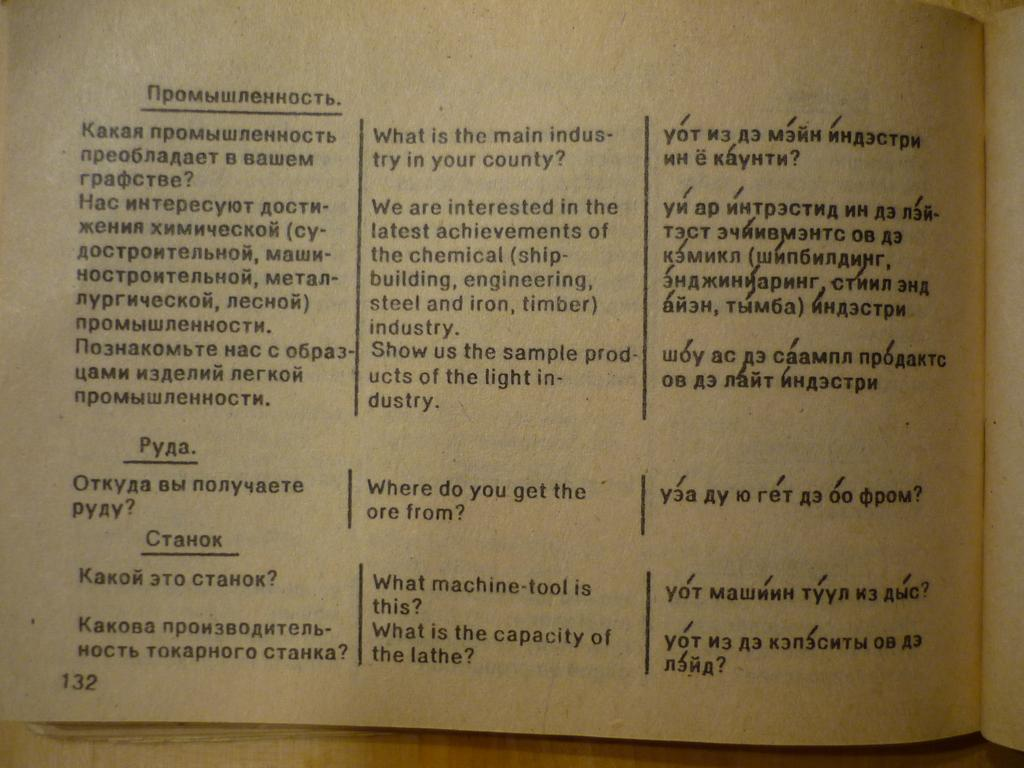<image>
Provide a brief description of the given image. A black and white page filled with foreign text. 